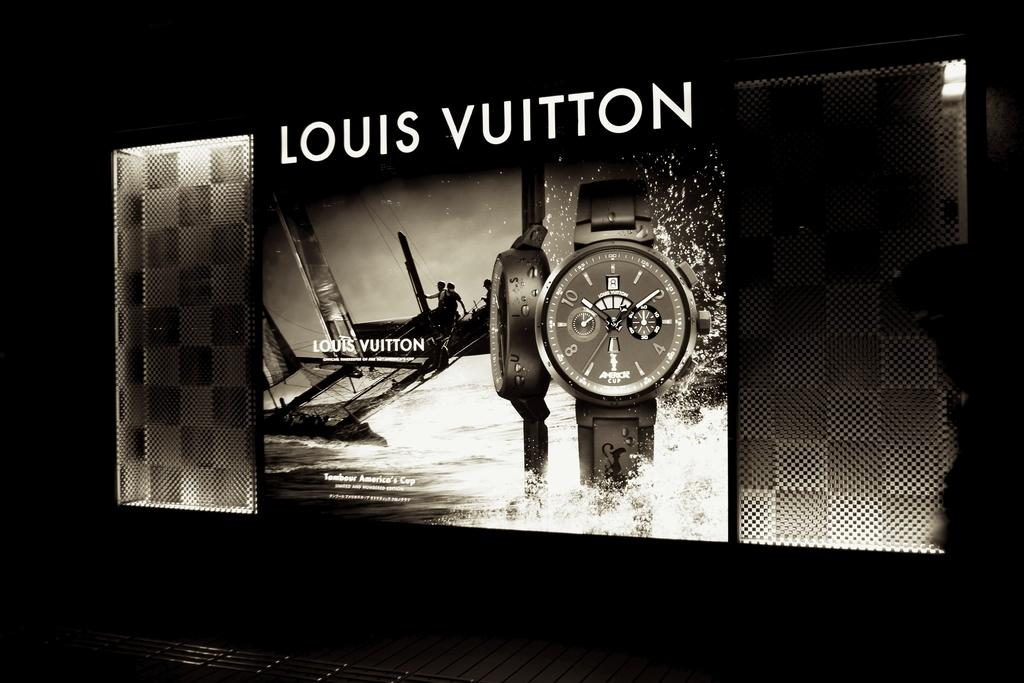<image>
Give a short and clear explanation of the subsequent image. Poster for a watch and says the words Louis Vuitton on it. 